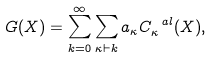Convert formula to latex. <formula><loc_0><loc_0><loc_500><loc_500>G ( X ) = \sum _ { k = 0 } ^ { \infty } \sum _ { \kappa \vdash k } a _ { \kappa } C _ { \kappa } ^ { \ a l } ( X ) ,</formula> 